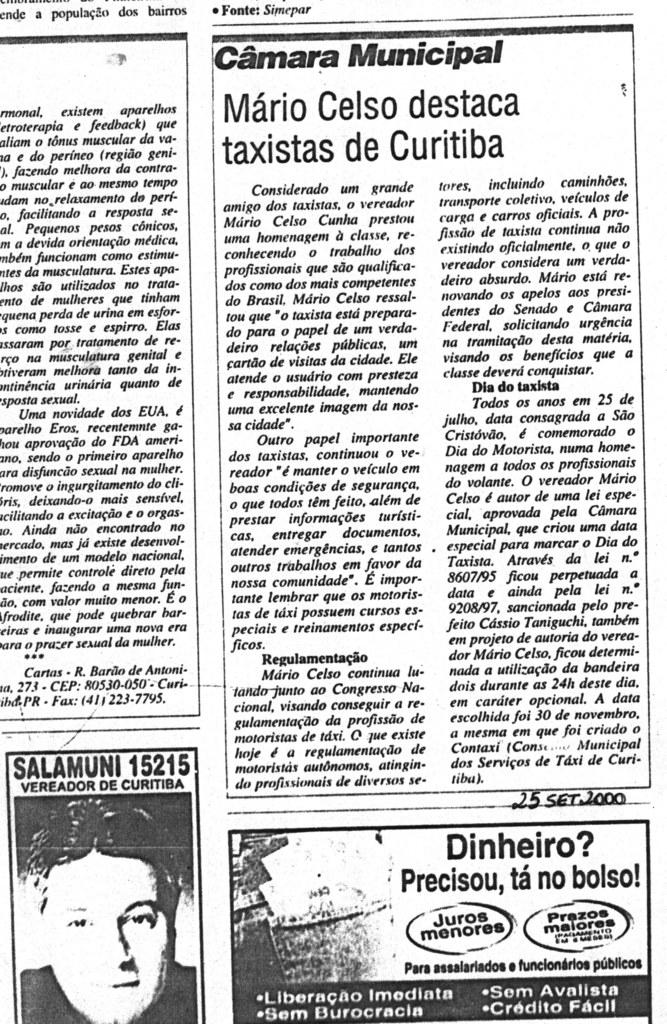What is the main subject of the image? The main subject of the image is a newspaper poster. What is depicted on the poster? There is a photo of a man's face on the poster. Are there any words or phrases on the poster? Yes, there are quotes on the poster. Can you see any flowers or plants in the garden depicted on the poster? There is no garden depicted on the poster; it features a photo of a man's face and quotes. What type of suit is the man wearing in the image? The image does not show the man wearing a suit; it only shows his face on the newspaper poster. 